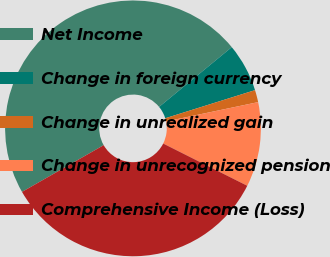Convert chart. <chart><loc_0><loc_0><loc_500><loc_500><pie_chart><fcel>Net Income<fcel>Change in foreign currency<fcel>Change in unrealized gain<fcel>Change in unrecognized pension<fcel>Comprehensive Income (Loss)<nl><fcel>47.32%<fcel>6.12%<fcel>1.54%<fcel>10.7%<fcel>34.31%<nl></chart> 